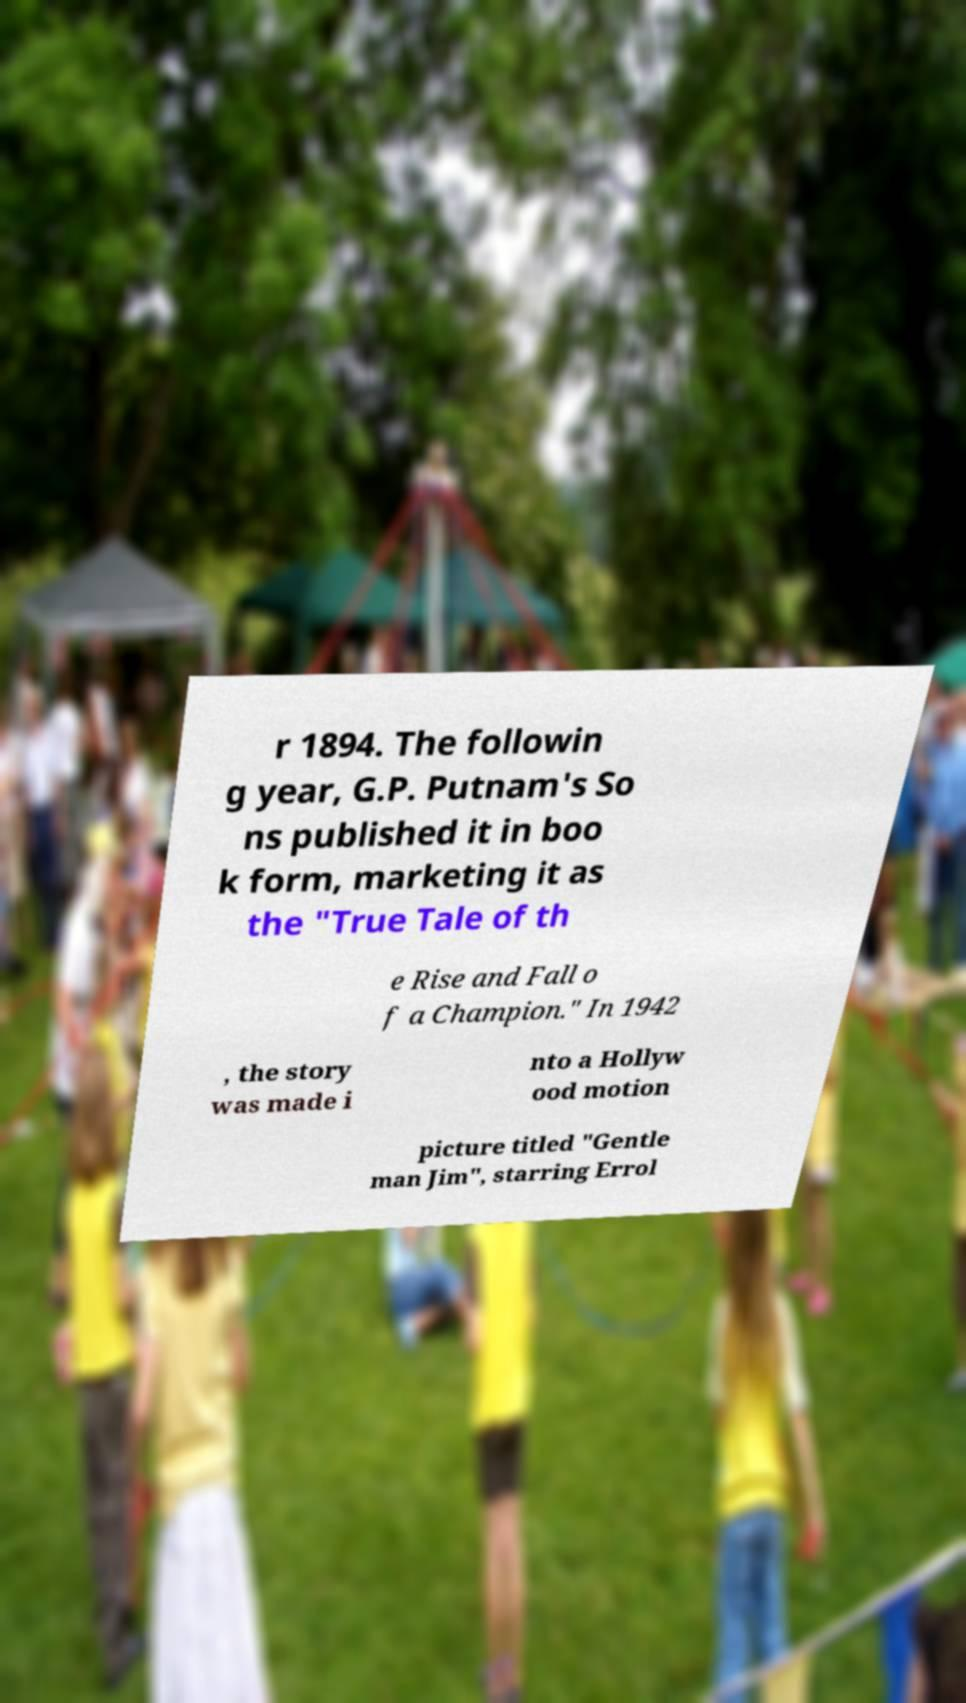Can you accurately transcribe the text from the provided image for me? r 1894. The followin g year, G.P. Putnam's So ns published it in boo k form, marketing it as the "True Tale of th e Rise and Fall o f a Champion." In 1942 , the story was made i nto a Hollyw ood motion picture titled "Gentle man Jim", starring Errol 